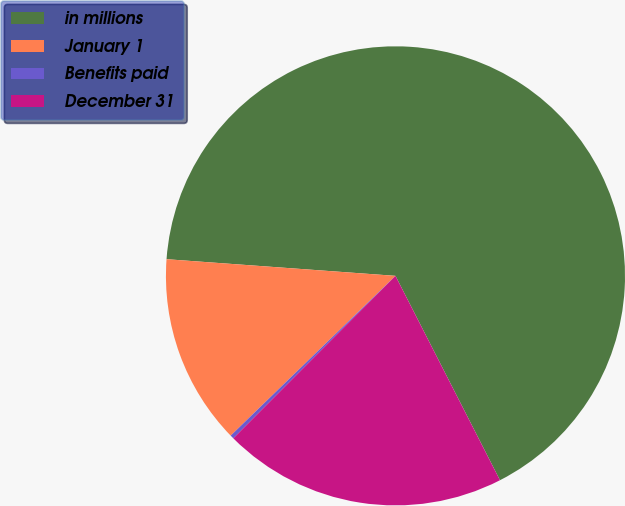Convert chart. <chart><loc_0><loc_0><loc_500><loc_500><pie_chart><fcel>in millions<fcel>January 1<fcel>Benefits paid<fcel>December 31<nl><fcel>66.32%<fcel>13.41%<fcel>0.26%<fcel>20.01%<nl></chart> 